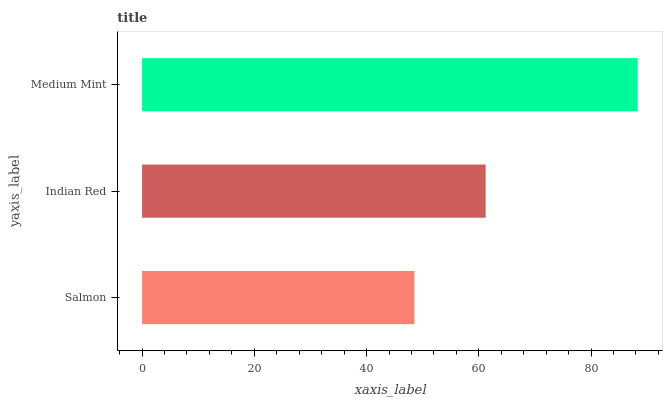Is Salmon the minimum?
Answer yes or no. Yes. Is Medium Mint the maximum?
Answer yes or no. Yes. Is Indian Red the minimum?
Answer yes or no. No. Is Indian Red the maximum?
Answer yes or no. No. Is Indian Red greater than Salmon?
Answer yes or no. Yes. Is Salmon less than Indian Red?
Answer yes or no. Yes. Is Salmon greater than Indian Red?
Answer yes or no. No. Is Indian Red less than Salmon?
Answer yes or no. No. Is Indian Red the high median?
Answer yes or no. Yes. Is Indian Red the low median?
Answer yes or no. Yes. Is Salmon the high median?
Answer yes or no. No. Is Salmon the low median?
Answer yes or no. No. 